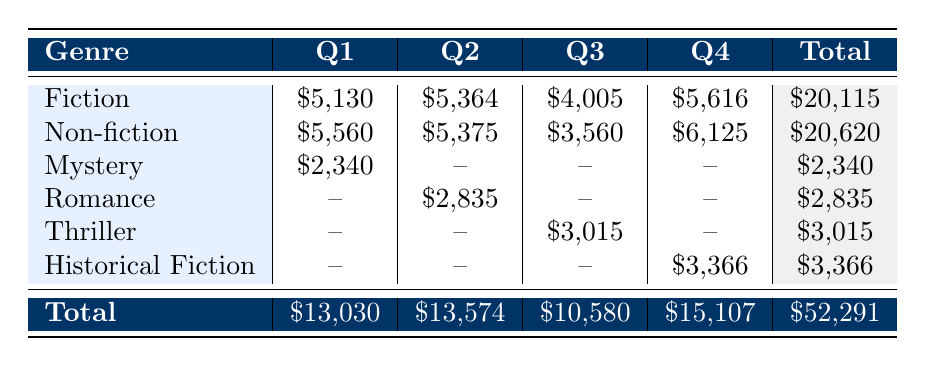What was the total revenue for Non-fiction books in Q3? The revenue for Non-fiction books in Q3 is listed as \$3,560.
Answer: \$3,560 Which genre generated the highest total revenue across all quarters? Summing the total revenue for each genre: Fiction: \$20,115, Non-fiction: \$20,620, Mystery: \$2,340, Romance: \$2,835, Thriller: \$3,015, Historical Fiction: \$3,366. The highest is Non-fiction at \$20,620.
Answer: Non-fiction Did Mystery books sell in Q2? There is no entry for Mystery in Q2 in the table.
Answer: No What is the average revenue of Romance books across the quarters where they were sold? Romance books made revenue only in Q2 with \$2,835. Since there is only one value, the average is \$2,835.
Answer: \$2,835 How much more revenue did Fiction books generate compared to Thriller books in Q4? Fiction generated \$5,616 and Thriller generated \$0 in Q4 (no data). Thus, \$5,616 - \$0 = \$5,616.
Answer: \$5,616 What was the total revenue for all genres combined in Q1? Adding the revenue in Q1 for each genre: \$5,130 (Fiction) + \$5,560 (Non-fiction) + \$2,340 (Mystery) = \$13,030.
Answer: \$13,030 Is Historical Fiction a genre that had sales recorded in Q1? There is no record of Historical Fiction in Q1 in the table.
Answer: No What is the total sales number for Fiction across all four quarters? Adding the sales for Fiction: 342 (Q1) + 298 (Q2) + 267 (Q3) + 312 (Q4) = 1,219.
Answer: 1,219 